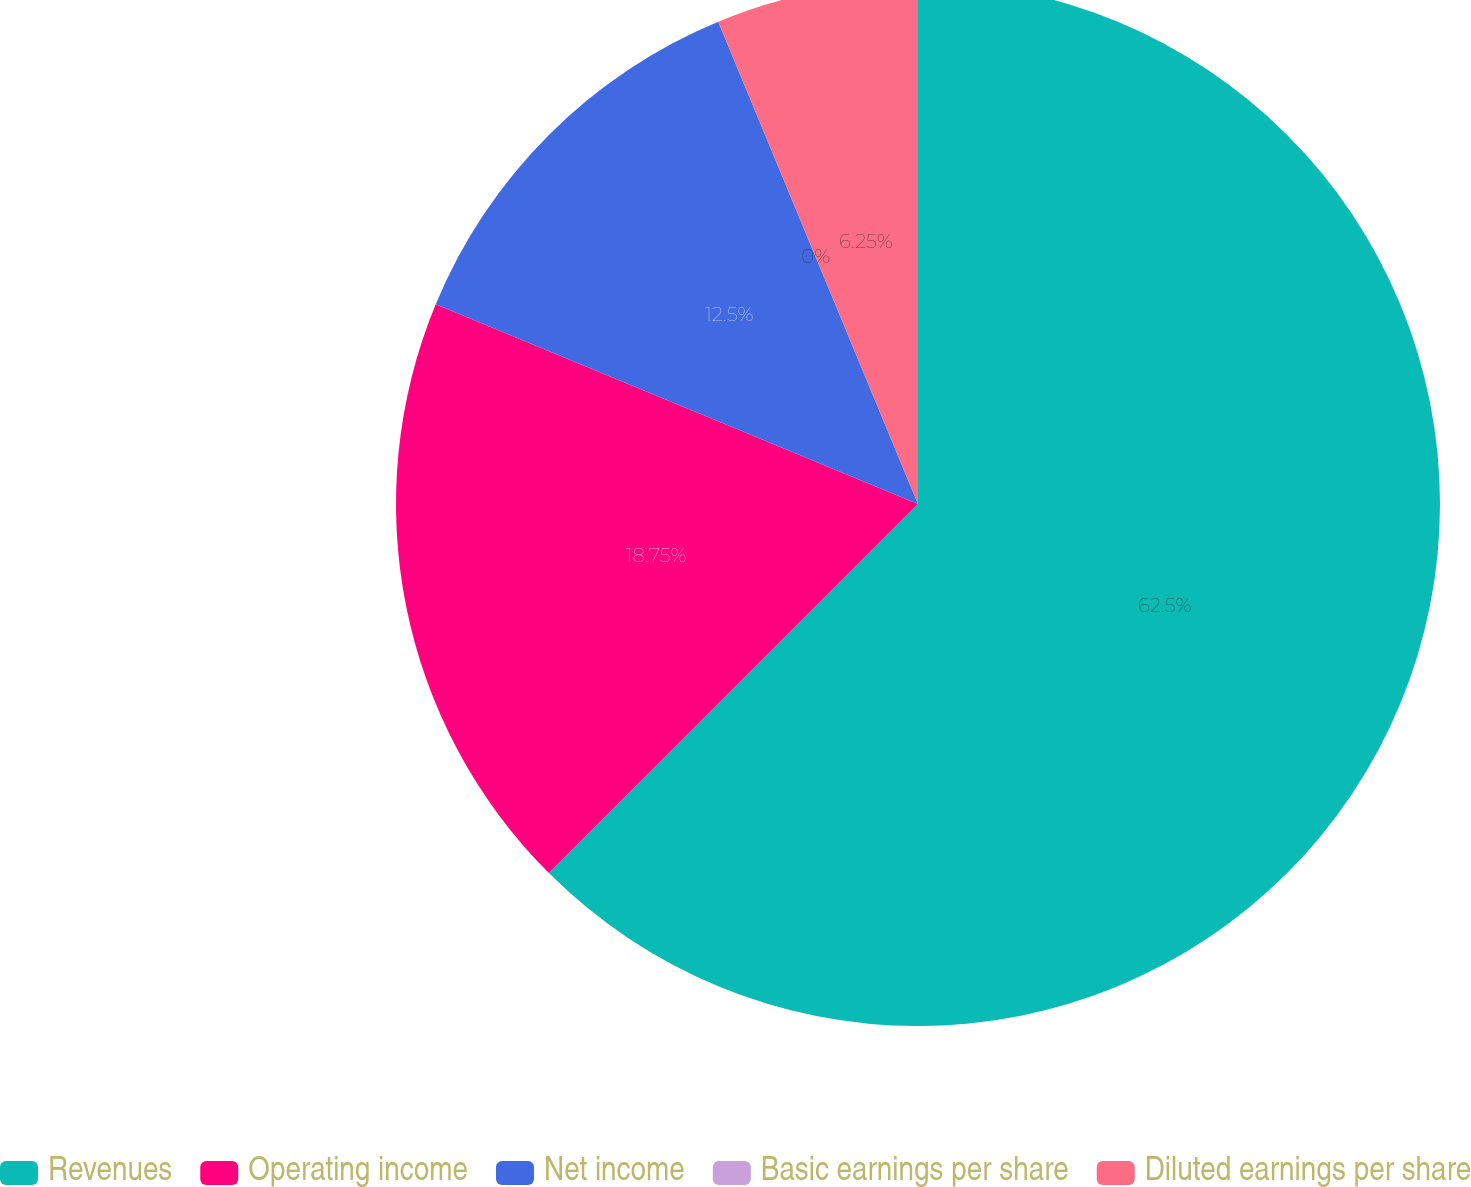Convert chart. <chart><loc_0><loc_0><loc_500><loc_500><pie_chart><fcel>Revenues<fcel>Operating income<fcel>Net income<fcel>Basic earnings per share<fcel>Diluted earnings per share<nl><fcel>62.5%<fcel>18.75%<fcel>12.5%<fcel>0.0%<fcel>6.25%<nl></chart> 